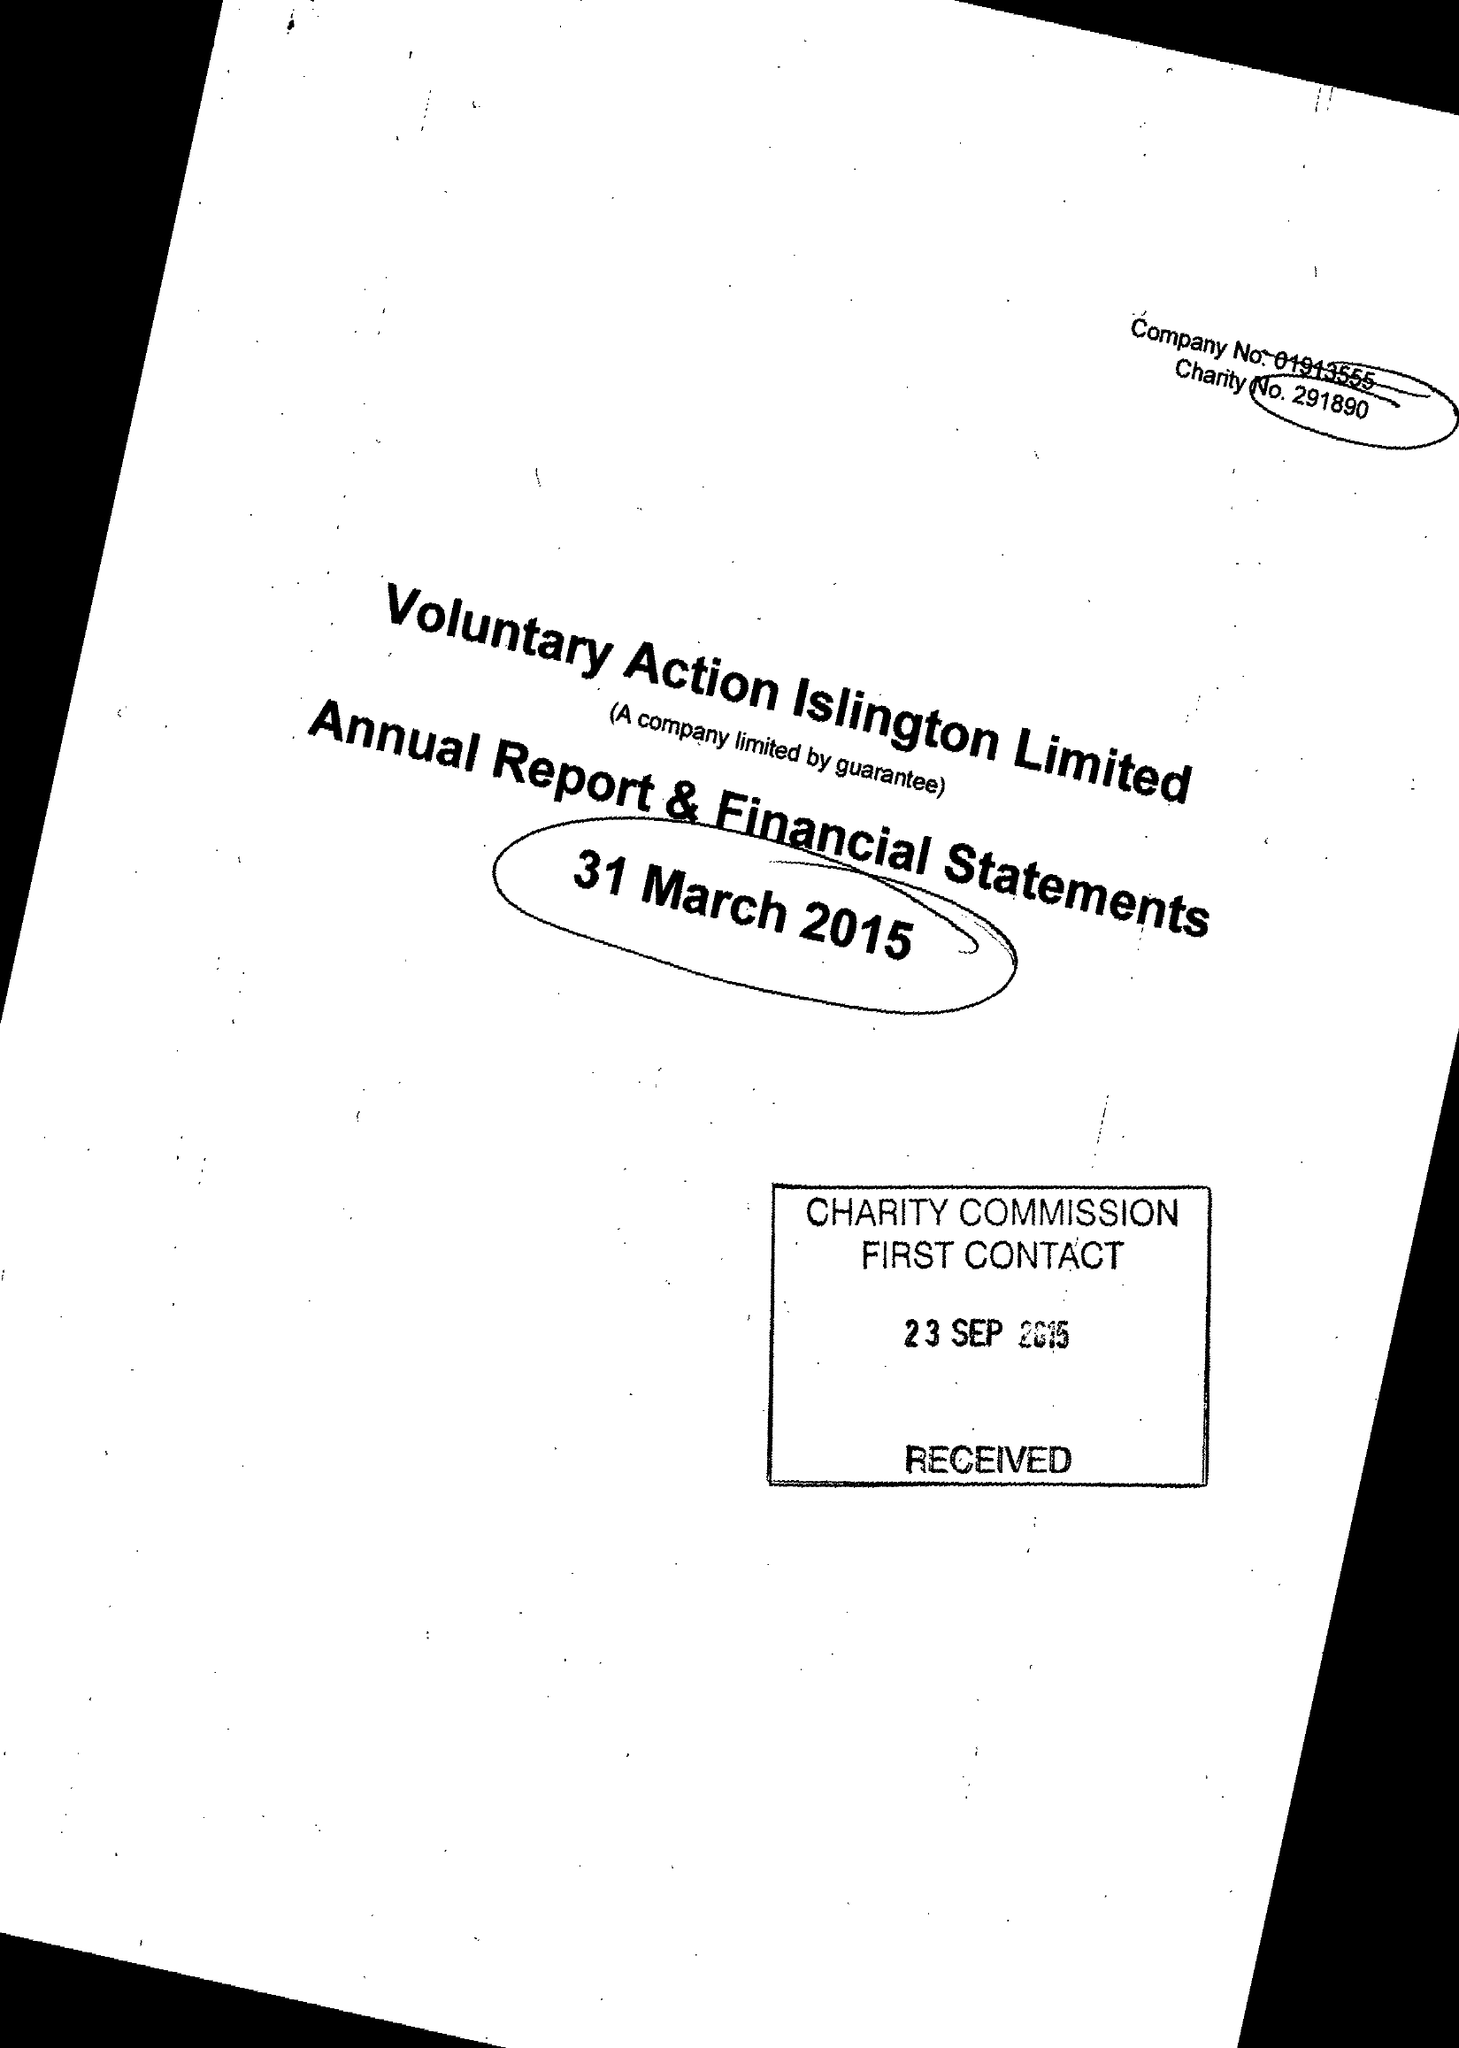What is the value for the charity_number?
Answer the question using a single word or phrase. 291890 